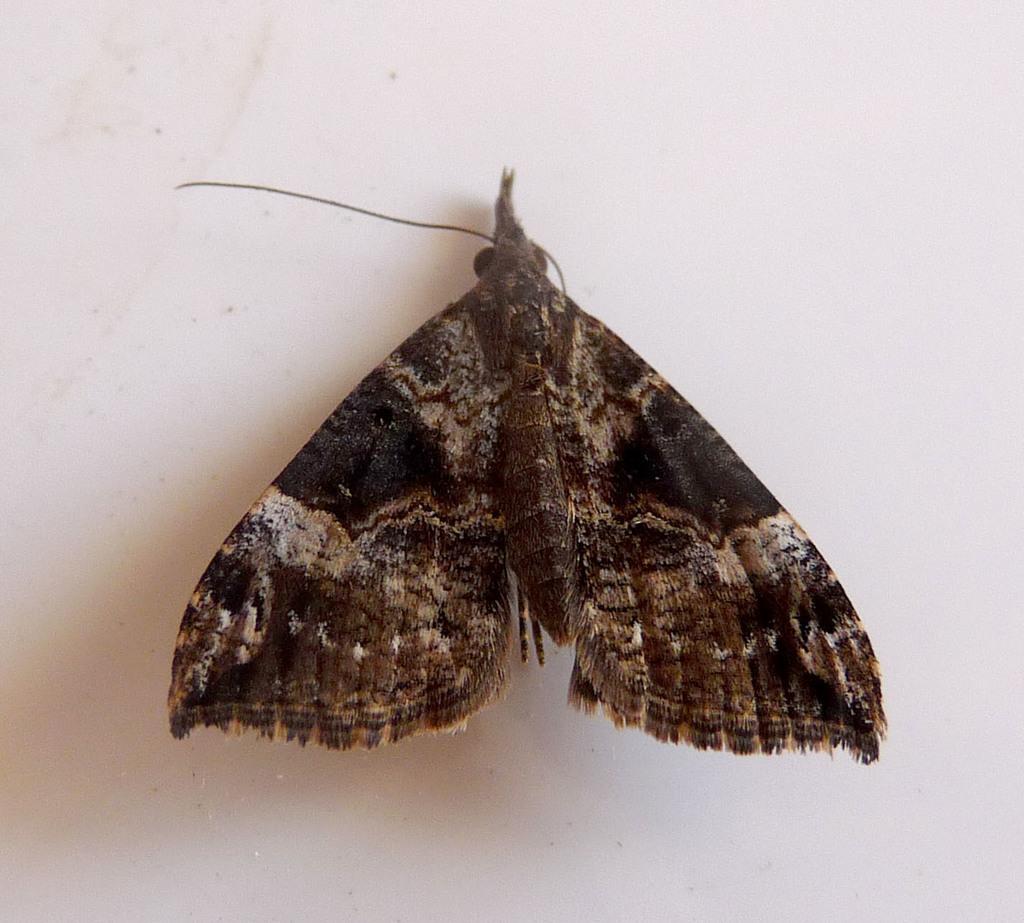In one or two sentences, can you explain what this image depicts? In this picture we can see a moth in the front, it looks like a wall in the background. 